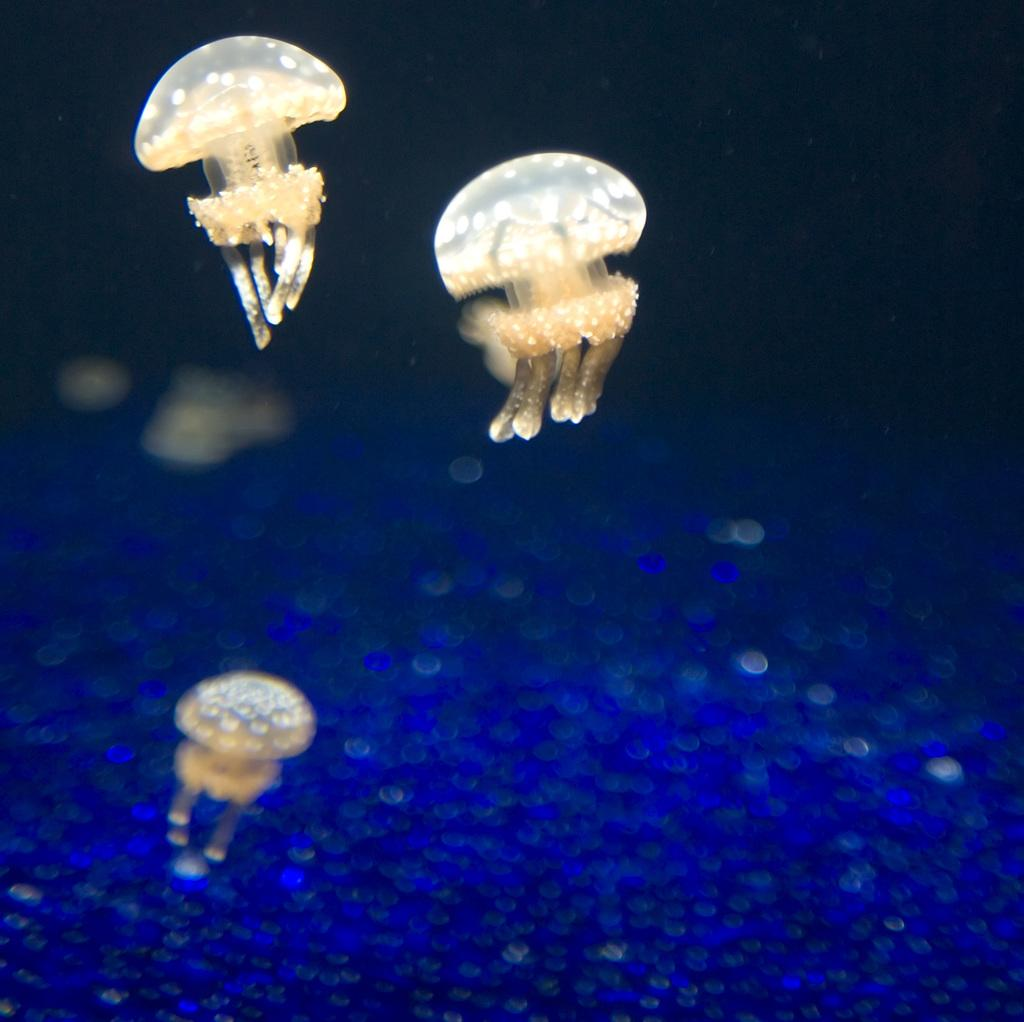What type of animals can be seen in the water in the image? There are jellyfishes in the water. Can you describe the environment in which the jellyfishes are located? The jellyfishes are located in the water. What is the distribution of the slip in the image? There is no slip present in the image, as it features jellyfishes in the water. 